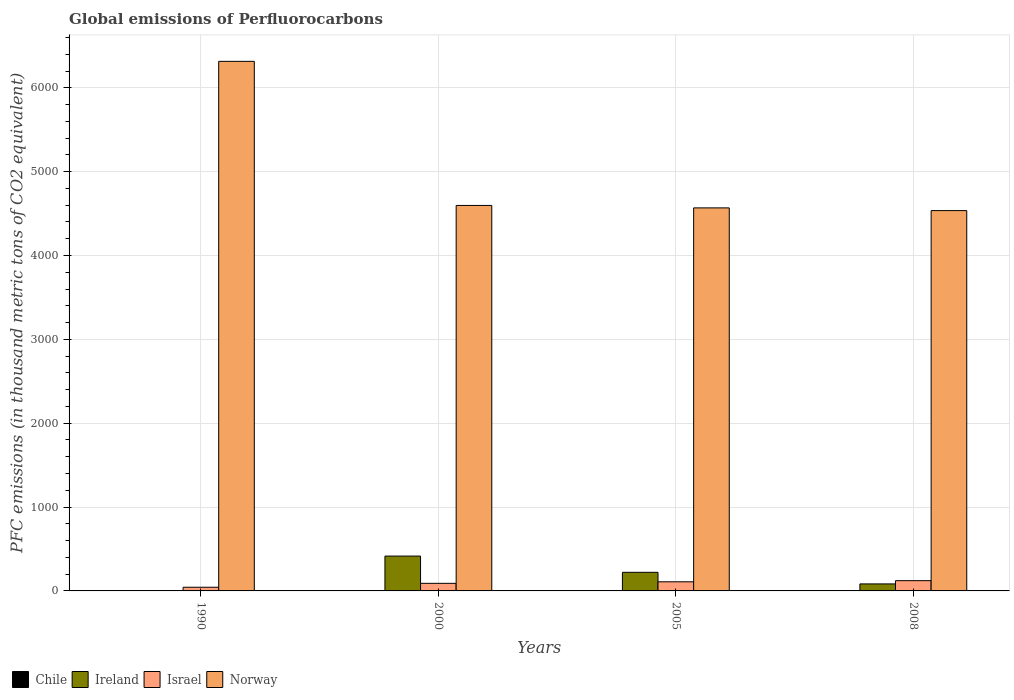Are the number of bars per tick equal to the number of legend labels?
Ensure brevity in your answer.  Yes. How many bars are there on the 3rd tick from the right?
Provide a short and direct response. 4. What is the global emissions of Perfluorocarbons in Israel in 2005?
Make the answer very short. 108.7. Across all years, what is the maximum global emissions of Perfluorocarbons in Chile?
Make the answer very short. 0.2. Across all years, what is the minimum global emissions of Perfluorocarbons in Norway?
Your response must be concise. 4535.7. In which year was the global emissions of Perfluorocarbons in Norway minimum?
Keep it short and to the point. 2008. What is the total global emissions of Perfluorocarbons in Ireland in the graph?
Offer a terse response. 722.4. What is the difference between the global emissions of Perfluorocarbons in Israel in 2000 and that in 2005?
Offer a very short reply. -18.2. What is the difference between the global emissions of Perfluorocarbons in Norway in 2000 and the global emissions of Perfluorocarbons in Israel in 1990?
Give a very brief answer. 4553.5. What is the average global emissions of Perfluorocarbons in Norway per year?
Make the answer very short. 5004.2. In the year 2008, what is the difference between the global emissions of Perfluorocarbons in Israel and global emissions of Perfluorocarbons in Chile?
Offer a very short reply. 122.1. In how many years, is the global emissions of Perfluorocarbons in Norway greater than 4800 thousand metric tons?
Your answer should be compact. 1. What is the ratio of the global emissions of Perfluorocarbons in Norway in 2005 to that in 2008?
Offer a very short reply. 1.01. Is the global emissions of Perfluorocarbons in Ireland in 2000 less than that in 2005?
Your response must be concise. No. Is the difference between the global emissions of Perfluorocarbons in Israel in 1990 and 2005 greater than the difference between the global emissions of Perfluorocarbons in Chile in 1990 and 2005?
Keep it short and to the point. No. What is the difference between the highest and the second highest global emissions of Perfluorocarbons in Israel?
Offer a terse response. 13.6. What is the difference between the highest and the lowest global emissions of Perfluorocarbons in Israel?
Keep it short and to the point. 78.5. In how many years, is the global emissions of Perfluorocarbons in Chile greater than the average global emissions of Perfluorocarbons in Chile taken over all years?
Keep it short and to the point. 0. Is the sum of the global emissions of Perfluorocarbons in Chile in 1990 and 2008 greater than the maximum global emissions of Perfluorocarbons in Israel across all years?
Offer a terse response. No. What does the 4th bar from the right in 1990 represents?
Your answer should be very brief. Chile. Is it the case that in every year, the sum of the global emissions of Perfluorocarbons in Ireland and global emissions of Perfluorocarbons in Chile is greater than the global emissions of Perfluorocarbons in Israel?
Make the answer very short. No. How many bars are there?
Offer a terse response. 16. Are all the bars in the graph horizontal?
Offer a terse response. No. How many years are there in the graph?
Make the answer very short. 4. Are the values on the major ticks of Y-axis written in scientific E-notation?
Offer a very short reply. No. Does the graph contain any zero values?
Your answer should be very brief. No. Does the graph contain grids?
Keep it short and to the point. Yes. Where does the legend appear in the graph?
Ensure brevity in your answer.  Bottom left. What is the title of the graph?
Offer a very short reply. Global emissions of Perfluorocarbons. Does "West Bank and Gaza" appear as one of the legend labels in the graph?
Your answer should be compact. No. What is the label or title of the Y-axis?
Your answer should be very brief. PFC emissions (in thousand metric tons of CO2 equivalent). What is the PFC emissions (in thousand metric tons of CO2 equivalent) in Chile in 1990?
Offer a very short reply. 0.2. What is the PFC emissions (in thousand metric tons of CO2 equivalent) in Israel in 1990?
Ensure brevity in your answer.  43.8. What is the PFC emissions (in thousand metric tons of CO2 equivalent) of Norway in 1990?
Offer a very short reply. 6315.7. What is the PFC emissions (in thousand metric tons of CO2 equivalent) in Chile in 2000?
Your response must be concise. 0.2. What is the PFC emissions (in thousand metric tons of CO2 equivalent) of Ireland in 2000?
Your answer should be very brief. 415.6. What is the PFC emissions (in thousand metric tons of CO2 equivalent) of Israel in 2000?
Give a very brief answer. 90.5. What is the PFC emissions (in thousand metric tons of CO2 equivalent) in Norway in 2000?
Ensure brevity in your answer.  4597.3. What is the PFC emissions (in thousand metric tons of CO2 equivalent) of Ireland in 2005?
Offer a terse response. 221.8. What is the PFC emissions (in thousand metric tons of CO2 equivalent) in Israel in 2005?
Make the answer very short. 108.7. What is the PFC emissions (in thousand metric tons of CO2 equivalent) in Norway in 2005?
Your response must be concise. 4568.1. What is the PFC emissions (in thousand metric tons of CO2 equivalent) in Chile in 2008?
Provide a succinct answer. 0.2. What is the PFC emissions (in thousand metric tons of CO2 equivalent) of Ireland in 2008?
Your answer should be very brief. 83.6. What is the PFC emissions (in thousand metric tons of CO2 equivalent) in Israel in 2008?
Provide a short and direct response. 122.3. What is the PFC emissions (in thousand metric tons of CO2 equivalent) in Norway in 2008?
Ensure brevity in your answer.  4535.7. Across all years, what is the maximum PFC emissions (in thousand metric tons of CO2 equivalent) of Ireland?
Give a very brief answer. 415.6. Across all years, what is the maximum PFC emissions (in thousand metric tons of CO2 equivalent) of Israel?
Offer a terse response. 122.3. Across all years, what is the maximum PFC emissions (in thousand metric tons of CO2 equivalent) in Norway?
Give a very brief answer. 6315.7. Across all years, what is the minimum PFC emissions (in thousand metric tons of CO2 equivalent) in Ireland?
Keep it short and to the point. 1.4. Across all years, what is the minimum PFC emissions (in thousand metric tons of CO2 equivalent) in Israel?
Your answer should be compact. 43.8. Across all years, what is the minimum PFC emissions (in thousand metric tons of CO2 equivalent) of Norway?
Your answer should be very brief. 4535.7. What is the total PFC emissions (in thousand metric tons of CO2 equivalent) in Chile in the graph?
Keep it short and to the point. 0.8. What is the total PFC emissions (in thousand metric tons of CO2 equivalent) of Ireland in the graph?
Your answer should be compact. 722.4. What is the total PFC emissions (in thousand metric tons of CO2 equivalent) in Israel in the graph?
Your response must be concise. 365.3. What is the total PFC emissions (in thousand metric tons of CO2 equivalent) in Norway in the graph?
Your answer should be compact. 2.00e+04. What is the difference between the PFC emissions (in thousand metric tons of CO2 equivalent) of Chile in 1990 and that in 2000?
Your answer should be compact. 0. What is the difference between the PFC emissions (in thousand metric tons of CO2 equivalent) in Ireland in 1990 and that in 2000?
Provide a short and direct response. -414.2. What is the difference between the PFC emissions (in thousand metric tons of CO2 equivalent) in Israel in 1990 and that in 2000?
Your answer should be compact. -46.7. What is the difference between the PFC emissions (in thousand metric tons of CO2 equivalent) in Norway in 1990 and that in 2000?
Keep it short and to the point. 1718.4. What is the difference between the PFC emissions (in thousand metric tons of CO2 equivalent) in Ireland in 1990 and that in 2005?
Your answer should be very brief. -220.4. What is the difference between the PFC emissions (in thousand metric tons of CO2 equivalent) in Israel in 1990 and that in 2005?
Provide a short and direct response. -64.9. What is the difference between the PFC emissions (in thousand metric tons of CO2 equivalent) of Norway in 1990 and that in 2005?
Your answer should be compact. 1747.6. What is the difference between the PFC emissions (in thousand metric tons of CO2 equivalent) of Chile in 1990 and that in 2008?
Your response must be concise. 0. What is the difference between the PFC emissions (in thousand metric tons of CO2 equivalent) of Ireland in 1990 and that in 2008?
Offer a very short reply. -82.2. What is the difference between the PFC emissions (in thousand metric tons of CO2 equivalent) in Israel in 1990 and that in 2008?
Your response must be concise. -78.5. What is the difference between the PFC emissions (in thousand metric tons of CO2 equivalent) of Norway in 1990 and that in 2008?
Offer a terse response. 1780. What is the difference between the PFC emissions (in thousand metric tons of CO2 equivalent) in Ireland in 2000 and that in 2005?
Make the answer very short. 193.8. What is the difference between the PFC emissions (in thousand metric tons of CO2 equivalent) of Israel in 2000 and that in 2005?
Give a very brief answer. -18.2. What is the difference between the PFC emissions (in thousand metric tons of CO2 equivalent) in Norway in 2000 and that in 2005?
Your response must be concise. 29.2. What is the difference between the PFC emissions (in thousand metric tons of CO2 equivalent) of Chile in 2000 and that in 2008?
Provide a short and direct response. 0. What is the difference between the PFC emissions (in thousand metric tons of CO2 equivalent) in Ireland in 2000 and that in 2008?
Provide a succinct answer. 332. What is the difference between the PFC emissions (in thousand metric tons of CO2 equivalent) in Israel in 2000 and that in 2008?
Your answer should be compact. -31.8. What is the difference between the PFC emissions (in thousand metric tons of CO2 equivalent) in Norway in 2000 and that in 2008?
Provide a short and direct response. 61.6. What is the difference between the PFC emissions (in thousand metric tons of CO2 equivalent) in Ireland in 2005 and that in 2008?
Your answer should be compact. 138.2. What is the difference between the PFC emissions (in thousand metric tons of CO2 equivalent) of Israel in 2005 and that in 2008?
Provide a succinct answer. -13.6. What is the difference between the PFC emissions (in thousand metric tons of CO2 equivalent) of Norway in 2005 and that in 2008?
Your response must be concise. 32.4. What is the difference between the PFC emissions (in thousand metric tons of CO2 equivalent) of Chile in 1990 and the PFC emissions (in thousand metric tons of CO2 equivalent) of Ireland in 2000?
Offer a very short reply. -415.4. What is the difference between the PFC emissions (in thousand metric tons of CO2 equivalent) in Chile in 1990 and the PFC emissions (in thousand metric tons of CO2 equivalent) in Israel in 2000?
Provide a succinct answer. -90.3. What is the difference between the PFC emissions (in thousand metric tons of CO2 equivalent) of Chile in 1990 and the PFC emissions (in thousand metric tons of CO2 equivalent) of Norway in 2000?
Your answer should be compact. -4597.1. What is the difference between the PFC emissions (in thousand metric tons of CO2 equivalent) of Ireland in 1990 and the PFC emissions (in thousand metric tons of CO2 equivalent) of Israel in 2000?
Provide a succinct answer. -89.1. What is the difference between the PFC emissions (in thousand metric tons of CO2 equivalent) of Ireland in 1990 and the PFC emissions (in thousand metric tons of CO2 equivalent) of Norway in 2000?
Make the answer very short. -4595.9. What is the difference between the PFC emissions (in thousand metric tons of CO2 equivalent) in Israel in 1990 and the PFC emissions (in thousand metric tons of CO2 equivalent) in Norway in 2000?
Your answer should be compact. -4553.5. What is the difference between the PFC emissions (in thousand metric tons of CO2 equivalent) in Chile in 1990 and the PFC emissions (in thousand metric tons of CO2 equivalent) in Ireland in 2005?
Keep it short and to the point. -221.6. What is the difference between the PFC emissions (in thousand metric tons of CO2 equivalent) of Chile in 1990 and the PFC emissions (in thousand metric tons of CO2 equivalent) of Israel in 2005?
Give a very brief answer. -108.5. What is the difference between the PFC emissions (in thousand metric tons of CO2 equivalent) in Chile in 1990 and the PFC emissions (in thousand metric tons of CO2 equivalent) in Norway in 2005?
Your answer should be very brief. -4567.9. What is the difference between the PFC emissions (in thousand metric tons of CO2 equivalent) in Ireland in 1990 and the PFC emissions (in thousand metric tons of CO2 equivalent) in Israel in 2005?
Provide a succinct answer. -107.3. What is the difference between the PFC emissions (in thousand metric tons of CO2 equivalent) of Ireland in 1990 and the PFC emissions (in thousand metric tons of CO2 equivalent) of Norway in 2005?
Your answer should be very brief. -4566.7. What is the difference between the PFC emissions (in thousand metric tons of CO2 equivalent) of Israel in 1990 and the PFC emissions (in thousand metric tons of CO2 equivalent) of Norway in 2005?
Give a very brief answer. -4524.3. What is the difference between the PFC emissions (in thousand metric tons of CO2 equivalent) of Chile in 1990 and the PFC emissions (in thousand metric tons of CO2 equivalent) of Ireland in 2008?
Give a very brief answer. -83.4. What is the difference between the PFC emissions (in thousand metric tons of CO2 equivalent) of Chile in 1990 and the PFC emissions (in thousand metric tons of CO2 equivalent) of Israel in 2008?
Your answer should be compact. -122.1. What is the difference between the PFC emissions (in thousand metric tons of CO2 equivalent) in Chile in 1990 and the PFC emissions (in thousand metric tons of CO2 equivalent) in Norway in 2008?
Offer a terse response. -4535.5. What is the difference between the PFC emissions (in thousand metric tons of CO2 equivalent) of Ireland in 1990 and the PFC emissions (in thousand metric tons of CO2 equivalent) of Israel in 2008?
Offer a terse response. -120.9. What is the difference between the PFC emissions (in thousand metric tons of CO2 equivalent) of Ireland in 1990 and the PFC emissions (in thousand metric tons of CO2 equivalent) of Norway in 2008?
Ensure brevity in your answer.  -4534.3. What is the difference between the PFC emissions (in thousand metric tons of CO2 equivalent) of Israel in 1990 and the PFC emissions (in thousand metric tons of CO2 equivalent) of Norway in 2008?
Offer a very short reply. -4491.9. What is the difference between the PFC emissions (in thousand metric tons of CO2 equivalent) in Chile in 2000 and the PFC emissions (in thousand metric tons of CO2 equivalent) in Ireland in 2005?
Provide a short and direct response. -221.6. What is the difference between the PFC emissions (in thousand metric tons of CO2 equivalent) of Chile in 2000 and the PFC emissions (in thousand metric tons of CO2 equivalent) of Israel in 2005?
Ensure brevity in your answer.  -108.5. What is the difference between the PFC emissions (in thousand metric tons of CO2 equivalent) of Chile in 2000 and the PFC emissions (in thousand metric tons of CO2 equivalent) of Norway in 2005?
Ensure brevity in your answer.  -4567.9. What is the difference between the PFC emissions (in thousand metric tons of CO2 equivalent) of Ireland in 2000 and the PFC emissions (in thousand metric tons of CO2 equivalent) of Israel in 2005?
Offer a very short reply. 306.9. What is the difference between the PFC emissions (in thousand metric tons of CO2 equivalent) in Ireland in 2000 and the PFC emissions (in thousand metric tons of CO2 equivalent) in Norway in 2005?
Offer a very short reply. -4152.5. What is the difference between the PFC emissions (in thousand metric tons of CO2 equivalent) in Israel in 2000 and the PFC emissions (in thousand metric tons of CO2 equivalent) in Norway in 2005?
Ensure brevity in your answer.  -4477.6. What is the difference between the PFC emissions (in thousand metric tons of CO2 equivalent) of Chile in 2000 and the PFC emissions (in thousand metric tons of CO2 equivalent) of Ireland in 2008?
Ensure brevity in your answer.  -83.4. What is the difference between the PFC emissions (in thousand metric tons of CO2 equivalent) of Chile in 2000 and the PFC emissions (in thousand metric tons of CO2 equivalent) of Israel in 2008?
Your response must be concise. -122.1. What is the difference between the PFC emissions (in thousand metric tons of CO2 equivalent) in Chile in 2000 and the PFC emissions (in thousand metric tons of CO2 equivalent) in Norway in 2008?
Your answer should be very brief. -4535.5. What is the difference between the PFC emissions (in thousand metric tons of CO2 equivalent) in Ireland in 2000 and the PFC emissions (in thousand metric tons of CO2 equivalent) in Israel in 2008?
Give a very brief answer. 293.3. What is the difference between the PFC emissions (in thousand metric tons of CO2 equivalent) of Ireland in 2000 and the PFC emissions (in thousand metric tons of CO2 equivalent) of Norway in 2008?
Your answer should be compact. -4120.1. What is the difference between the PFC emissions (in thousand metric tons of CO2 equivalent) in Israel in 2000 and the PFC emissions (in thousand metric tons of CO2 equivalent) in Norway in 2008?
Provide a succinct answer. -4445.2. What is the difference between the PFC emissions (in thousand metric tons of CO2 equivalent) of Chile in 2005 and the PFC emissions (in thousand metric tons of CO2 equivalent) of Ireland in 2008?
Offer a very short reply. -83.4. What is the difference between the PFC emissions (in thousand metric tons of CO2 equivalent) in Chile in 2005 and the PFC emissions (in thousand metric tons of CO2 equivalent) in Israel in 2008?
Offer a terse response. -122.1. What is the difference between the PFC emissions (in thousand metric tons of CO2 equivalent) of Chile in 2005 and the PFC emissions (in thousand metric tons of CO2 equivalent) of Norway in 2008?
Your answer should be very brief. -4535.5. What is the difference between the PFC emissions (in thousand metric tons of CO2 equivalent) of Ireland in 2005 and the PFC emissions (in thousand metric tons of CO2 equivalent) of Israel in 2008?
Your response must be concise. 99.5. What is the difference between the PFC emissions (in thousand metric tons of CO2 equivalent) of Ireland in 2005 and the PFC emissions (in thousand metric tons of CO2 equivalent) of Norway in 2008?
Provide a succinct answer. -4313.9. What is the difference between the PFC emissions (in thousand metric tons of CO2 equivalent) of Israel in 2005 and the PFC emissions (in thousand metric tons of CO2 equivalent) of Norway in 2008?
Ensure brevity in your answer.  -4427. What is the average PFC emissions (in thousand metric tons of CO2 equivalent) of Ireland per year?
Your answer should be very brief. 180.6. What is the average PFC emissions (in thousand metric tons of CO2 equivalent) of Israel per year?
Your answer should be compact. 91.33. What is the average PFC emissions (in thousand metric tons of CO2 equivalent) of Norway per year?
Offer a terse response. 5004.2. In the year 1990, what is the difference between the PFC emissions (in thousand metric tons of CO2 equivalent) in Chile and PFC emissions (in thousand metric tons of CO2 equivalent) in Ireland?
Your answer should be compact. -1.2. In the year 1990, what is the difference between the PFC emissions (in thousand metric tons of CO2 equivalent) in Chile and PFC emissions (in thousand metric tons of CO2 equivalent) in Israel?
Your response must be concise. -43.6. In the year 1990, what is the difference between the PFC emissions (in thousand metric tons of CO2 equivalent) in Chile and PFC emissions (in thousand metric tons of CO2 equivalent) in Norway?
Offer a very short reply. -6315.5. In the year 1990, what is the difference between the PFC emissions (in thousand metric tons of CO2 equivalent) in Ireland and PFC emissions (in thousand metric tons of CO2 equivalent) in Israel?
Keep it short and to the point. -42.4. In the year 1990, what is the difference between the PFC emissions (in thousand metric tons of CO2 equivalent) of Ireland and PFC emissions (in thousand metric tons of CO2 equivalent) of Norway?
Ensure brevity in your answer.  -6314.3. In the year 1990, what is the difference between the PFC emissions (in thousand metric tons of CO2 equivalent) of Israel and PFC emissions (in thousand metric tons of CO2 equivalent) of Norway?
Ensure brevity in your answer.  -6271.9. In the year 2000, what is the difference between the PFC emissions (in thousand metric tons of CO2 equivalent) in Chile and PFC emissions (in thousand metric tons of CO2 equivalent) in Ireland?
Ensure brevity in your answer.  -415.4. In the year 2000, what is the difference between the PFC emissions (in thousand metric tons of CO2 equivalent) in Chile and PFC emissions (in thousand metric tons of CO2 equivalent) in Israel?
Provide a succinct answer. -90.3. In the year 2000, what is the difference between the PFC emissions (in thousand metric tons of CO2 equivalent) in Chile and PFC emissions (in thousand metric tons of CO2 equivalent) in Norway?
Your answer should be very brief. -4597.1. In the year 2000, what is the difference between the PFC emissions (in thousand metric tons of CO2 equivalent) of Ireland and PFC emissions (in thousand metric tons of CO2 equivalent) of Israel?
Give a very brief answer. 325.1. In the year 2000, what is the difference between the PFC emissions (in thousand metric tons of CO2 equivalent) of Ireland and PFC emissions (in thousand metric tons of CO2 equivalent) of Norway?
Provide a succinct answer. -4181.7. In the year 2000, what is the difference between the PFC emissions (in thousand metric tons of CO2 equivalent) of Israel and PFC emissions (in thousand metric tons of CO2 equivalent) of Norway?
Your response must be concise. -4506.8. In the year 2005, what is the difference between the PFC emissions (in thousand metric tons of CO2 equivalent) in Chile and PFC emissions (in thousand metric tons of CO2 equivalent) in Ireland?
Offer a terse response. -221.6. In the year 2005, what is the difference between the PFC emissions (in thousand metric tons of CO2 equivalent) in Chile and PFC emissions (in thousand metric tons of CO2 equivalent) in Israel?
Your answer should be compact. -108.5. In the year 2005, what is the difference between the PFC emissions (in thousand metric tons of CO2 equivalent) of Chile and PFC emissions (in thousand metric tons of CO2 equivalent) of Norway?
Ensure brevity in your answer.  -4567.9. In the year 2005, what is the difference between the PFC emissions (in thousand metric tons of CO2 equivalent) of Ireland and PFC emissions (in thousand metric tons of CO2 equivalent) of Israel?
Make the answer very short. 113.1. In the year 2005, what is the difference between the PFC emissions (in thousand metric tons of CO2 equivalent) in Ireland and PFC emissions (in thousand metric tons of CO2 equivalent) in Norway?
Offer a very short reply. -4346.3. In the year 2005, what is the difference between the PFC emissions (in thousand metric tons of CO2 equivalent) in Israel and PFC emissions (in thousand metric tons of CO2 equivalent) in Norway?
Provide a succinct answer. -4459.4. In the year 2008, what is the difference between the PFC emissions (in thousand metric tons of CO2 equivalent) in Chile and PFC emissions (in thousand metric tons of CO2 equivalent) in Ireland?
Ensure brevity in your answer.  -83.4. In the year 2008, what is the difference between the PFC emissions (in thousand metric tons of CO2 equivalent) of Chile and PFC emissions (in thousand metric tons of CO2 equivalent) of Israel?
Provide a short and direct response. -122.1. In the year 2008, what is the difference between the PFC emissions (in thousand metric tons of CO2 equivalent) in Chile and PFC emissions (in thousand metric tons of CO2 equivalent) in Norway?
Your response must be concise. -4535.5. In the year 2008, what is the difference between the PFC emissions (in thousand metric tons of CO2 equivalent) of Ireland and PFC emissions (in thousand metric tons of CO2 equivalent) of Israel?
Provide a short and direct response. -38.7. In the year 2008, what is the difference between the PFC emissions (in thousand metric tons of CO2 equivalent) in Ireland and PFC emissions (in thousand metric tons of CO2 equivalent) in Norway?
Your response must be concise. -4452.1. In the year 2008, what is the difference between the PFC emissions (in thousand metric tons of CO2 equivalent) of Israel and PFC emissions (in thousand metric tons of CO2 equivalent) of Norway?
Make the answer very short. -4413.4. What is the ratio of the PFC emissions (in thousand metric tons of CO2 equivalent) in Chile in 1990 to that in 2000?
Offer a very short reply. 1. What is the ratio of the PFC emissions (in thousand metric tons of CO2 equivalent) in Ireland in 1990 to that in 2000?
Ensure brevity in your answer.  0. What is the ratio of the PFC emissions (in thousand metric tons of CO2 equivalent) in Israel in 1990 to that in 2000?
Provide a succinct answer. 0.48. What is the ratio of the PFC emissions (in thousand metric tons of CO2 equivalent) in Norway in 1990 to that in 2000?
Offer a terse response. 1.37. What is the ratio of the PFC emissions (in thousand metric tons of CO2 equivalent) of Chile in 1990 to that in 2005?
Make the answer very short. 1. What is the ratio of the PFC emissions (in thousand metric tons of CO2 equivalent) in Ireland in 1990 to that in 2005?
Make the answer very short. 0.01. What is the ratio of the PFC emissions (in thousand metric tons of CO2 equivalent) of Israel in 1990 to that in 2005?
Your answer should be compact. 0.4. What is the ratio of the PFC emissions (in thousand metric tons of CO2 equivalent) in Norway in 1990 to that in 2005?
Make the answer very short. 1.38. What is the ratio of the PFC emissions (in thousand metric tons of CO2 equivalent) of Chile in 1990 to that in 2008?
Your answer should be compact. 1. What is the ratio of the PFC emissions (in thousand metric tons of CO2 equivalent) of Ireland in 1990 to that in 2008?
Keep it short and to the point. 0.02. What is the ratio of the PFC emissions (in thousand metric tons of CO2 equivalent) of Israel in 1990 to that in 2008?
Make the answer very short. 0.36. What is the ratio of the PFC emissions (in thousand metric tons of CO2 equivalent) in Norway in 1990 to that in 2008?
Offer a terse response. 1.39. What is the ratio of the PFC emissions (in thousand metric tons of CO2 equivalent) of Ireland in 2000 to that in 2005?
Provide a short and direct response. 1.87. What is the ratio of the PFC emissions (in thousand metric tons of CO2 equivalent) in Israel in 2000 to that in 2005?
Provide a succinct answer. 0.83. What is the ratio of the PFC emissions (in thousand metric tons of CO2 equivalent) of Norway in 2000 to that in 2005?
Provide a short and direct response. 1.01. What is the ratio of the PFC emissions (in thousand metric tons of CO2 equivalent) of Ireland in 2000 to that in 2008?
Offer a very short reply. 4.97. What is the ratio of the PFC emissions (in thousand metric tons of CO2 equivalent) of Israel in 2000 to that in 2008?
Ensure brevity in your answer.  0.74. What is the ratio of the PFC emissions (in thousand metric tons of CO2 equivalent) in Norway in 2000 to that in 2008?
Offer a terse response. 1.01. What is the ratio of the PFC emissions (in thousand metric tons of CO2 equivalent) of Ireland in 2005 to that in 2008?
Your answer should be compact. 2.65. What is the ratio of the PFC emissions (in thousand metric tons of CO2 equivalent) in Israel in 2005 to that in 2008?
Provide a short and direct response. 0.89. What is the ratio of the PFC emissions (in thousand metric tons of CO2 equivalent) in Norway in 2005 to that in 2008?
Offer a very short reply. 1.01. What is the difference between the highest and the second highest PFC emissions (in thousand metric tons of CO2 equivalent) in Ireland?
Offer a very short reply. 193.8. What is the difference between the highest and the second highest PFC emissions (in thousand metric tons of CO2 equivalent) in Israel?
Your answer should be very brief. 13.6. What is the difference between the highest and the second highest PFC emissions (in thousand metric tons of CO2 equivalent) in Norway?
Provide a short and direct response. 1718.4. What is the difference between the highest and the lowest PFC emissions (in thousand metric tons of CO2 equivalent) of Ireland?
Give a very brief answer. 414.2. What is the difference between the highest and the lowest PFC emissions (in thousand metric tons of CO2 equivalent) of Israel?
Give a very brief answer. 78.5. What is the difference between the highest and the lowest PFC emissions (in thousand metric tons of CO2 equivalent) in Norway?
Give a very brief answer. 1780. 